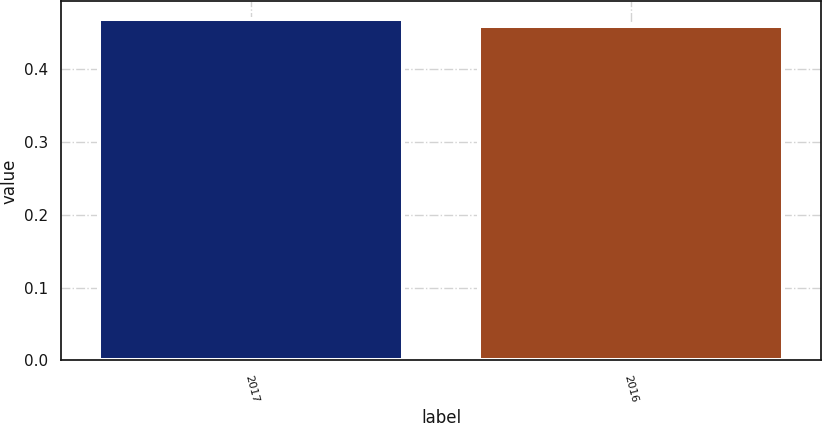<chart> <loc_0><loc_0><loc_500><loc_500><bar_chart><fcel>2017<fcel>2016<nl><fcel>0.47<fcel>0.46<nl></chart> 